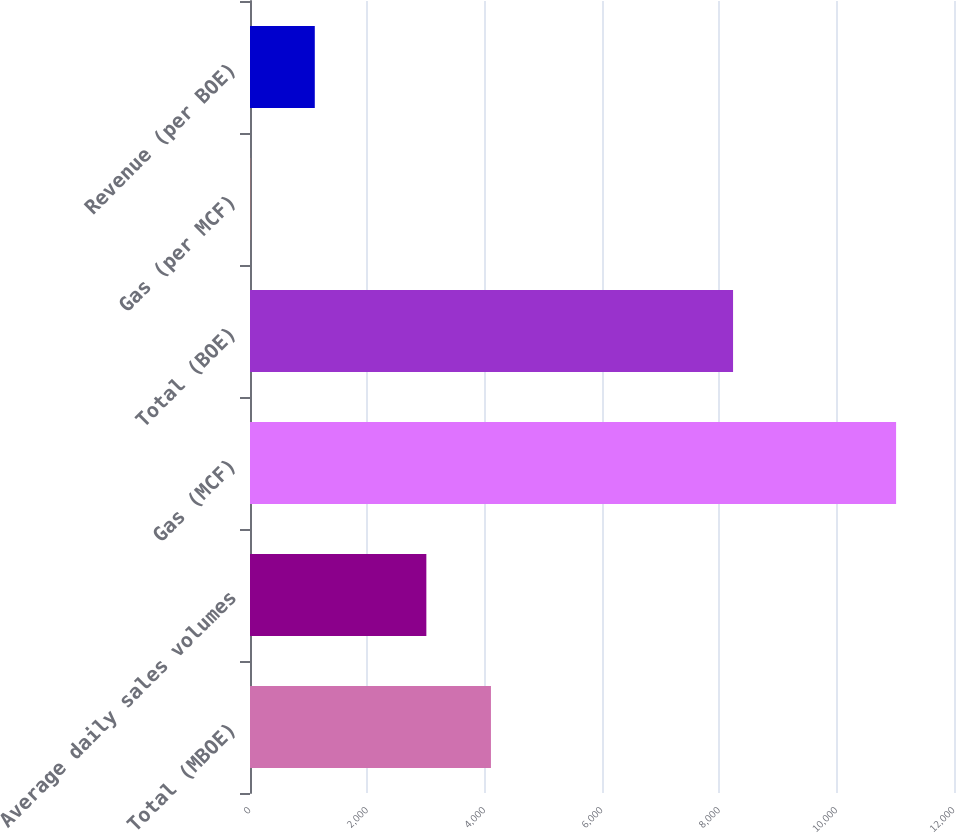<chart> <loc_0><loc_0><loc_500><loc_500><bar_chart><fcel>Total (MBOE)<fcel>Average daily sales volumes<fcel>Gas (MCF)<fcel>Total (BOE)<fcel>Gas (per MCF)<fcel>Revenue (per BOE)<nl><fcel>4106.96<fcel>3006<fcel>11013<fcel>8234<fcel>3.41<fcel>1104.37<nl></chart> 